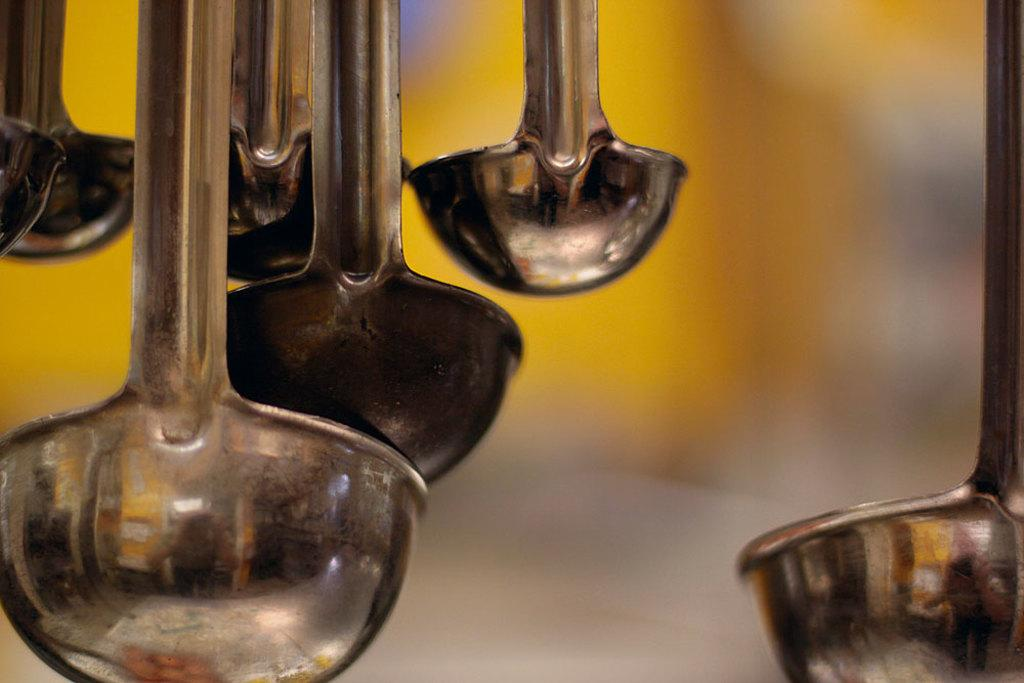What objects are hanging in the image? There are spoons hanging in the image. Can you describe the background of the image? The background of the image is blurry. How many frogs can be seen sitting on the coat in the image? There are no frogs or coats present in the image. 